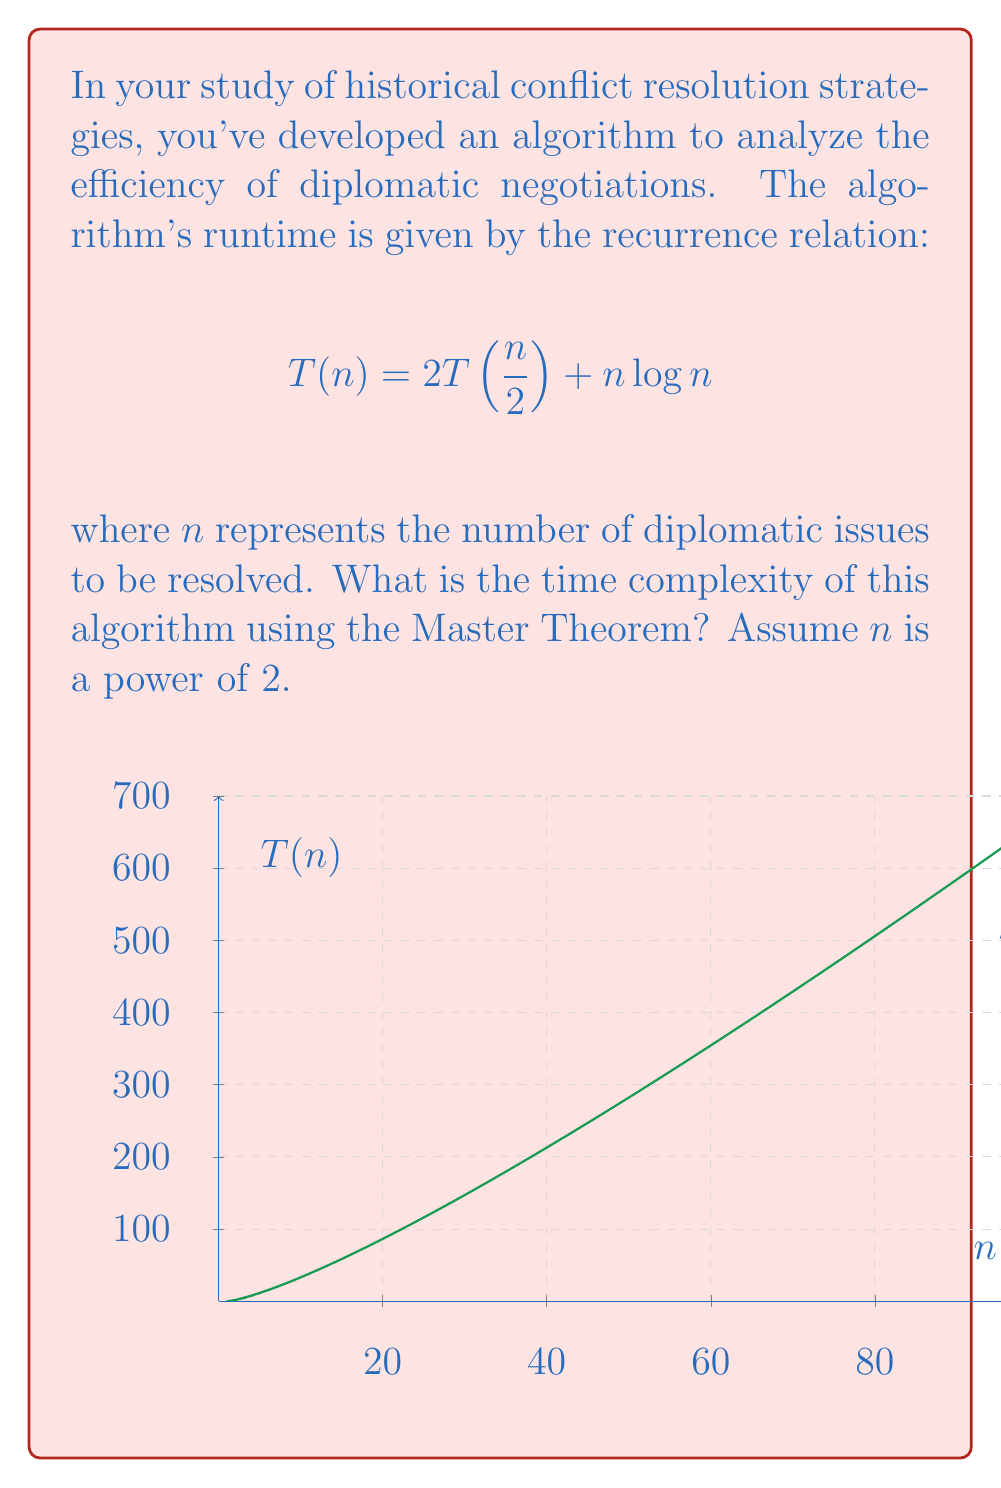Show me your answer to this math problem. To solve this problem, we'll use the Master Theorem, which is a powerful tool for analyzing divide-and-conquer algorithms. The Master Theorem states that for a recurrence of the form:

$$T(n) = aT(\frac{n}{b}) + f(n)$$

where $a \geq 1$, $b > 1$, and $f(n)$ is a positive function, the time complexity can be determined by comparing $f(n)$ with $n^{\log_b a}$.

In our case:
$a = 2$ (number of subproblems)
$b = 2$ (factor by which the problem size is reduced)
$f(n) = n\log n$

Step 1: Calculate $n^{\log_b a}$
$$n^{\log_b a} = n^{\log_2 2} = n^1 = n$$

Step 2: Compare $f(n)$ with $n^{\log_b a}$
$f(n) = n\log n$ and $n^{\log_b a} = n$

We see that $f(n) = \Omega(n^{\log_b a} \log^k n)$ for $k = 1$

Step 3: Apply the Master Theorem
Since $f(n) = \Omega(n^{\log_b a} \log^k n)$ for $k \geq 0$, we fall into case 3 of the Master Theorem:

If $f(n) = \Omega(n^{\log_b a} \log^k n)$ for some constant $k \geq 0$, and if $af(\frac{n}{b}) \leq cf(n)$ for some constant $c < 1$ and sufficiently large $n$, then:

$$T(n) = \Theta(f(n))$$

We need to verify the regularity condition:

$$af(\frac{n}{b}) \leq cf(n)$$
$$2(\frac{n}{2}\log\frac{n}{2}) \leq cn\log n$$
$$n\log\frac{n}{2} \leq cn\log n$$
$$\log n - 1 \leq c\log n$$

This inequality holds for $c = 1$ and sufficiently large $n$.

Therefore, we can conclude that:

$$T(n) = \Theta(n\log n)$$
Answer: $\Theta(n\log n)$ 